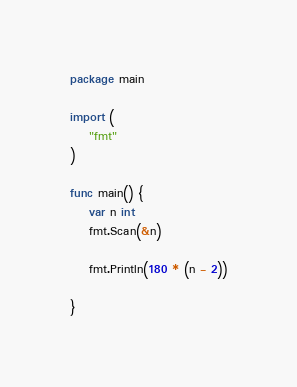<code> <loc_0><loc_0><loc_500><loc_500><_Go_>package main

import (
	"fmt"
)

func main() {
	var n int
	fmt.Scan(&n)
	
	fmt.Println(180 * (n - 2))

}</code> 